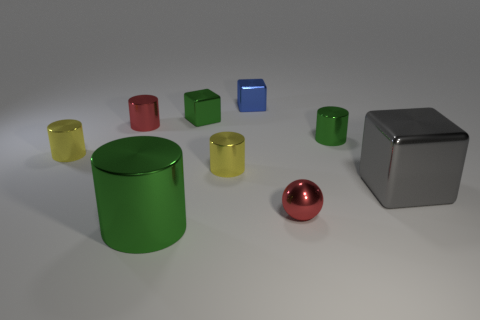Are there any gray objects that have the same shape as the big green shiny thing?
Your answer should be compact. No. How many red metallic objects are the same shape as the gray thing?
Offer a very short reply. 0. Is the sphere the same color as the large cylinder?
Provide a short and direct response. No. Are there fewer large green shiny objects than small gray rubber cylinders?
Give a very brief answer. No. What is the material of the thing in front of the ball?
Your answer should be very brief. Metal. What material is the green cube that is the same size as the blue thing?
Offer a very short reply. Metal. What material is the yellow cylinder that is in front of the metal thing that is left of the small red object behind the large shiny cube?
Your answer should be very brief. Metal. Is the size of the green metallic cylinder that is in front of the gray object the same as the small green metallic cube?
Give a very brief answer. No. Is the number of big purple metallic things greater than the number of small yellow metal cylinders?
Offer a terse response. No. What number of big objects are green shiny cylinders or yellow metallic cylinders?
Your response must be concise. 1. 